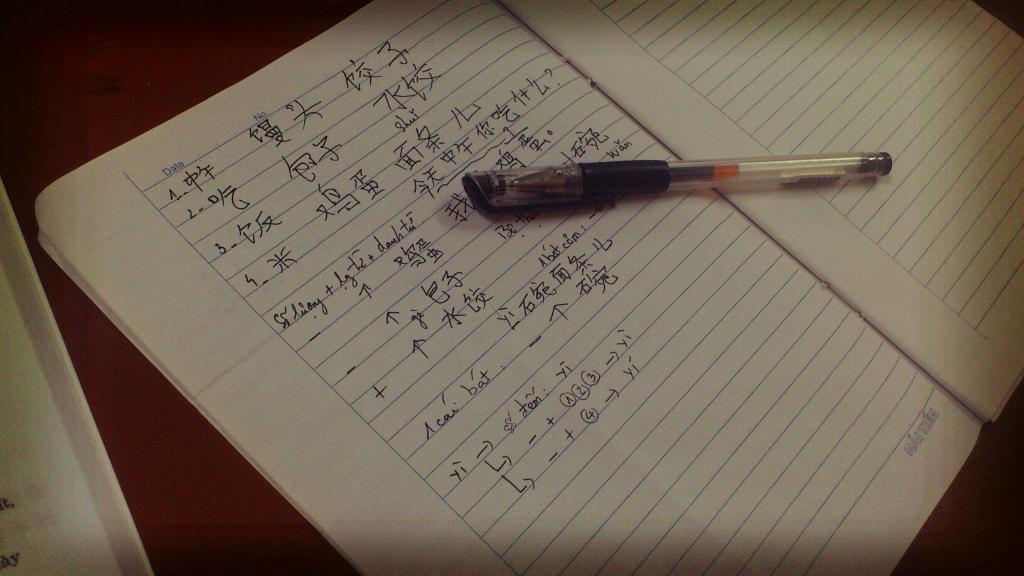Describe this image in one or two sentences. In this image I can see a pen and the book. To the side I can see an another book. These are on the brown color surface. 